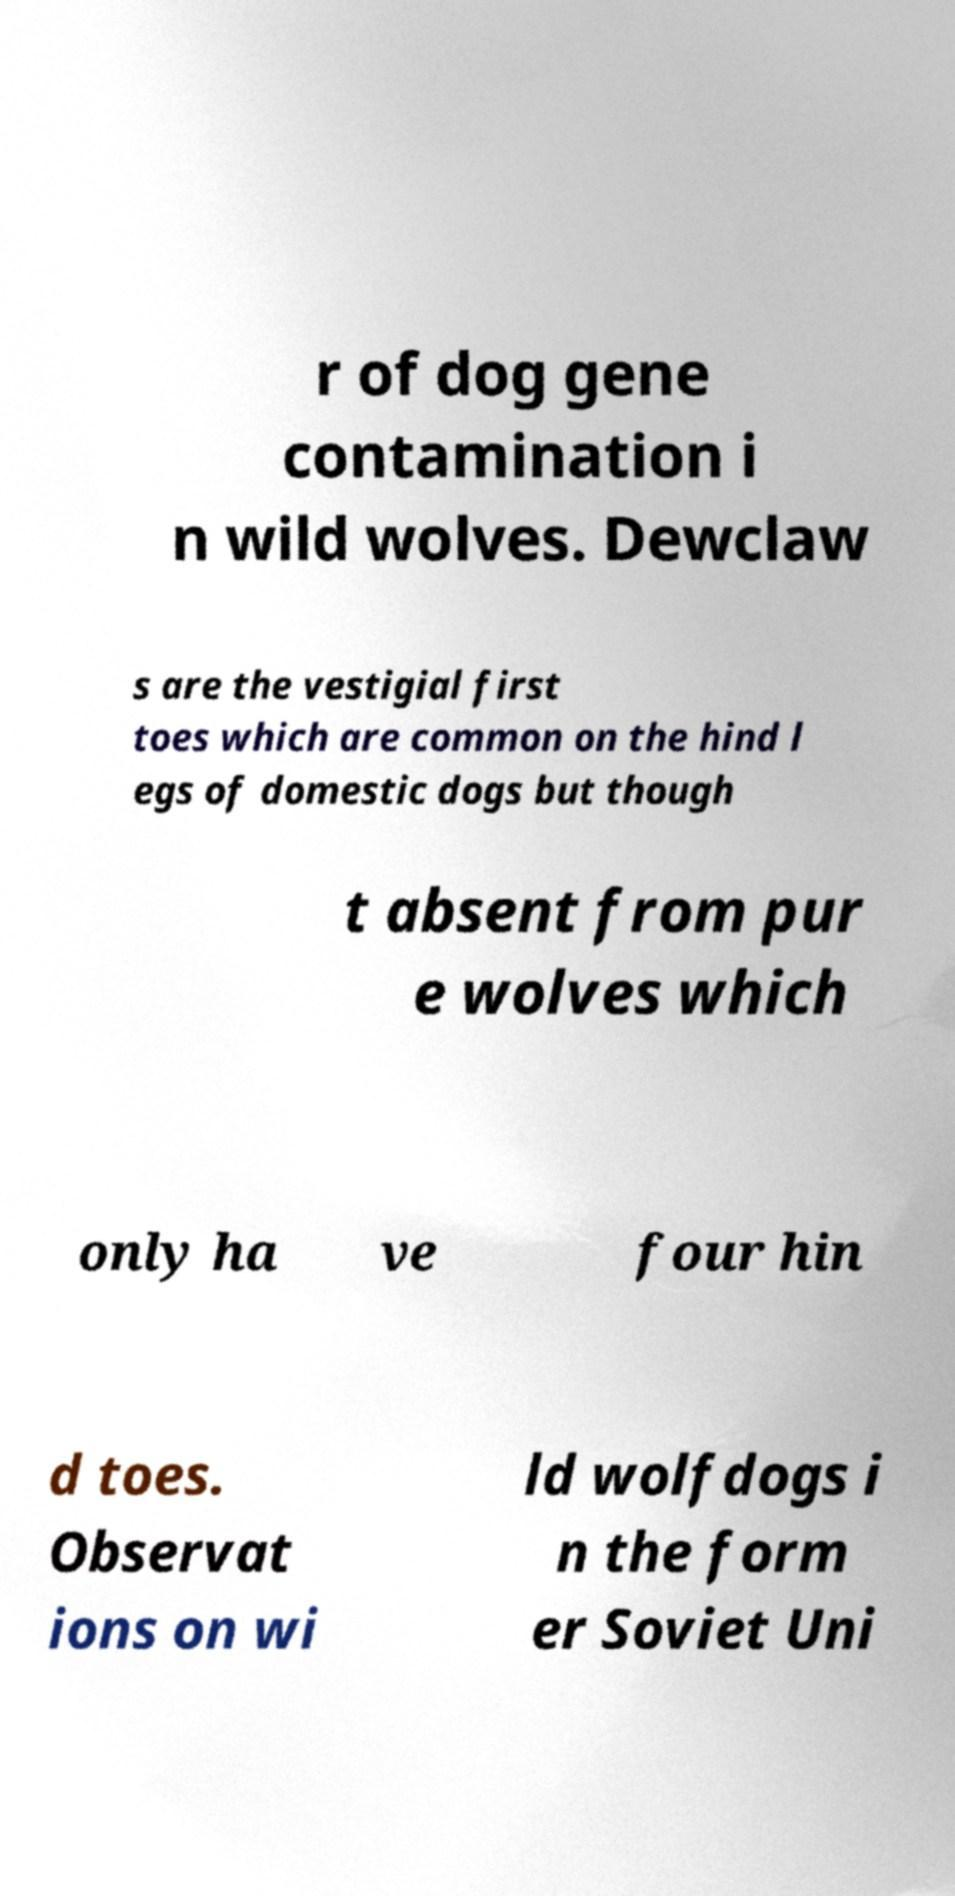For documentation purposes, I need the text within this image transcribed. Could you provide that? r of dog gene contamination i n wild wolves. Dewclaw s are the vestigial first toes which are common on the hind l egs of domestic dogs but though t absent from pur e wolves which only ha ve four hin d toes. Observat ions on wi ld wolfdogs i n the form er Soviet Uni 